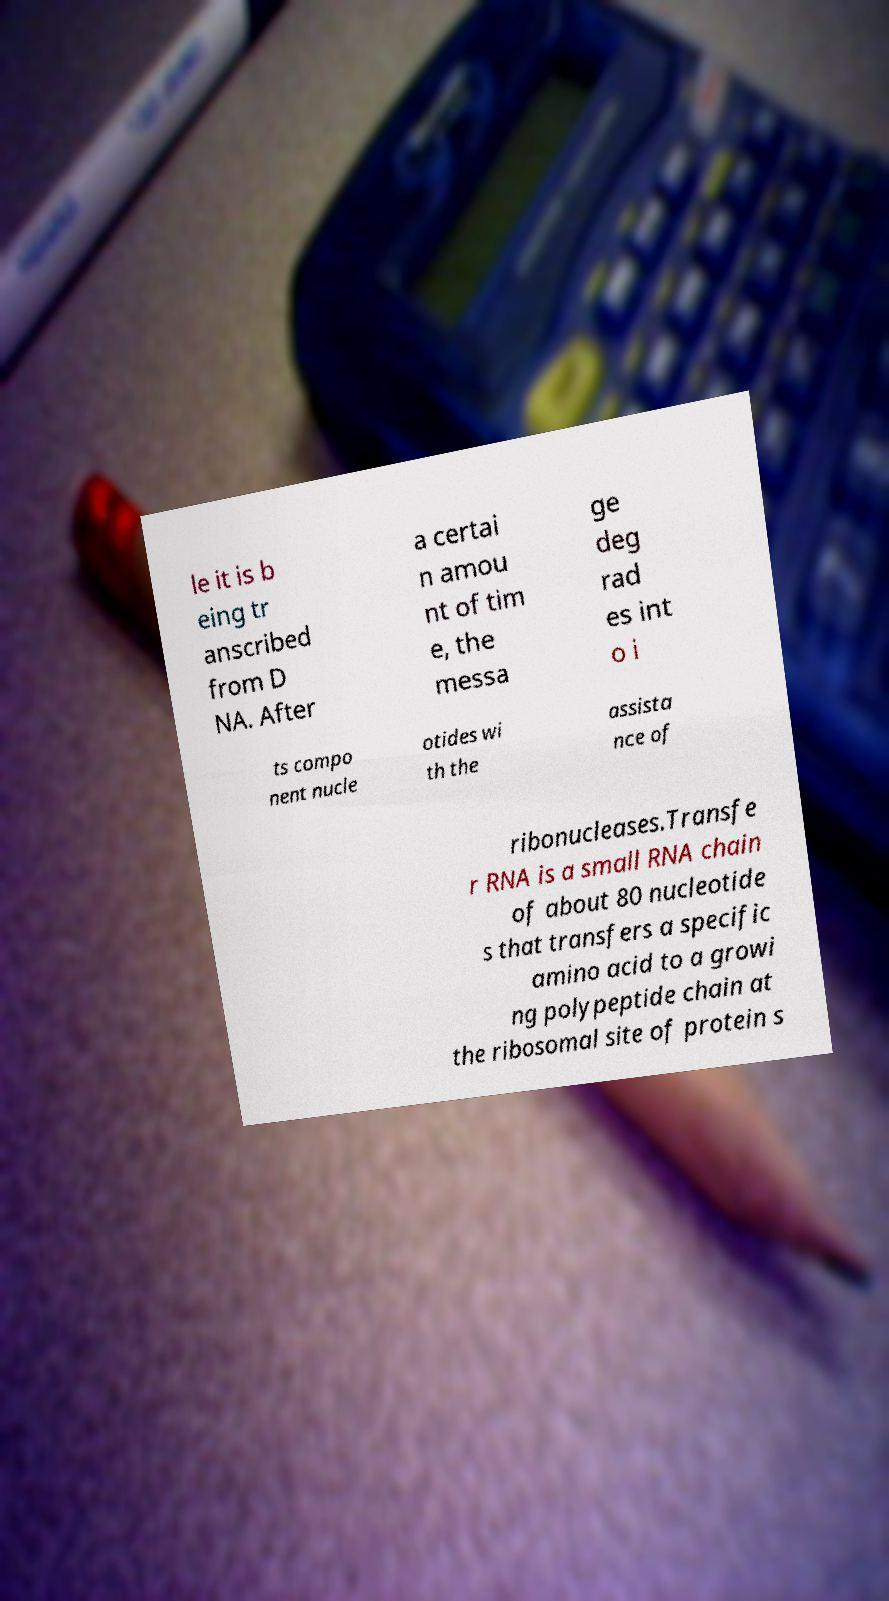There's text embedded in this image that I need extracted. Can you transcribe it verbatim? le it is b eing tr anscribed from D NA. After a certai n amou nt of tim e, the messa ge deg rad es int o i ts compo nent nucle otides wi th the assista nce of ribonucleases.Transfe r RNA is a small RNA chain of about 80 nucleotide s that transfers a specific amino acid to a growi ng polypeptide chain at the ribosomal site of protein s 